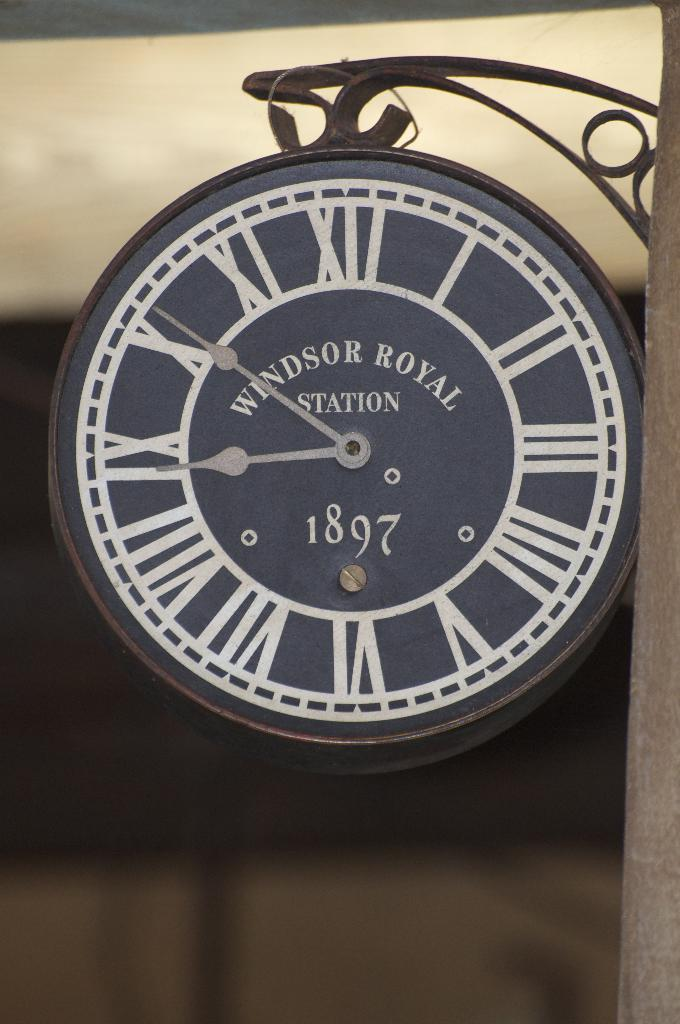<image>
Share a concise interpretation of the image provided. A clock that says Windsor Royal Station and 1897 on the face of it. 